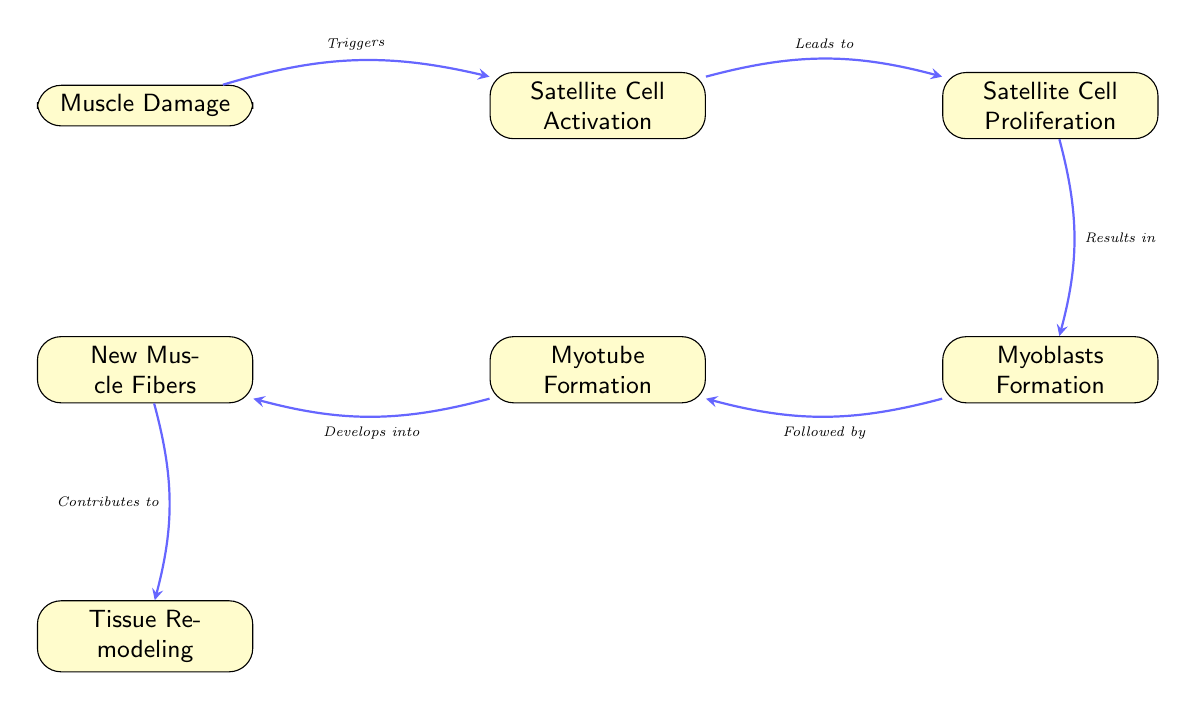What triggers satellite cell activation? The diagram indicates that muscle damage triggers satellite cell activation. This is the only connection leading to the activation of satellite cells.
Answer: Muscle Damage What follows myoblasts formation? According to the diagram, myoblasts formation is followed by myotube formation. There is a direct edge showing this sequence of events.
Answer: Myotube Formation How many nodes are in the diagram? Counting the distinct nodes in the diagram, there are six nodes: Muscle Damage, Satellite Cell Activation, Satellite Cell Proliferation, Myoblasts Formation, Myotube Formation, and New Muscle Fibers.
Answer: Six What contributes to tissue remodeling? The diagram shows that new muscle fibers contribute to tissue remodeling. This is indicated by the directed edge from new muscle fibers to tissue remodeling.
Answer: New Muscle Fibers What is formed from myotube formation? According to the diagram, myotube formation develops into new muscle fibers. This relationship is established with an arrow leading from myotube formation to new muscle fibers.
Answer: New Muscle Fibers Which process is followed by satellite cell proliferation? The process that follows satellite cell proliferation is myoblasts formation as depicted by the directed edge in the diagram indicating progression.
Answer: Myoblasts Formation What is the relationship between muscle damage and satellite cell activation? The relationship is that muscle damage triggers satellite cell activation, indicating a cause-and-effect chain, which is visually represented by the directed edge in the diagram.
Answer: Triggers Which step directly precedes tissue remodeling? The step that directly precedes tissue remodeling is the formation of new muscle fibers, as shown by the directed edge leading into tissue remodeling.
Answer: New Muscle Fibers 